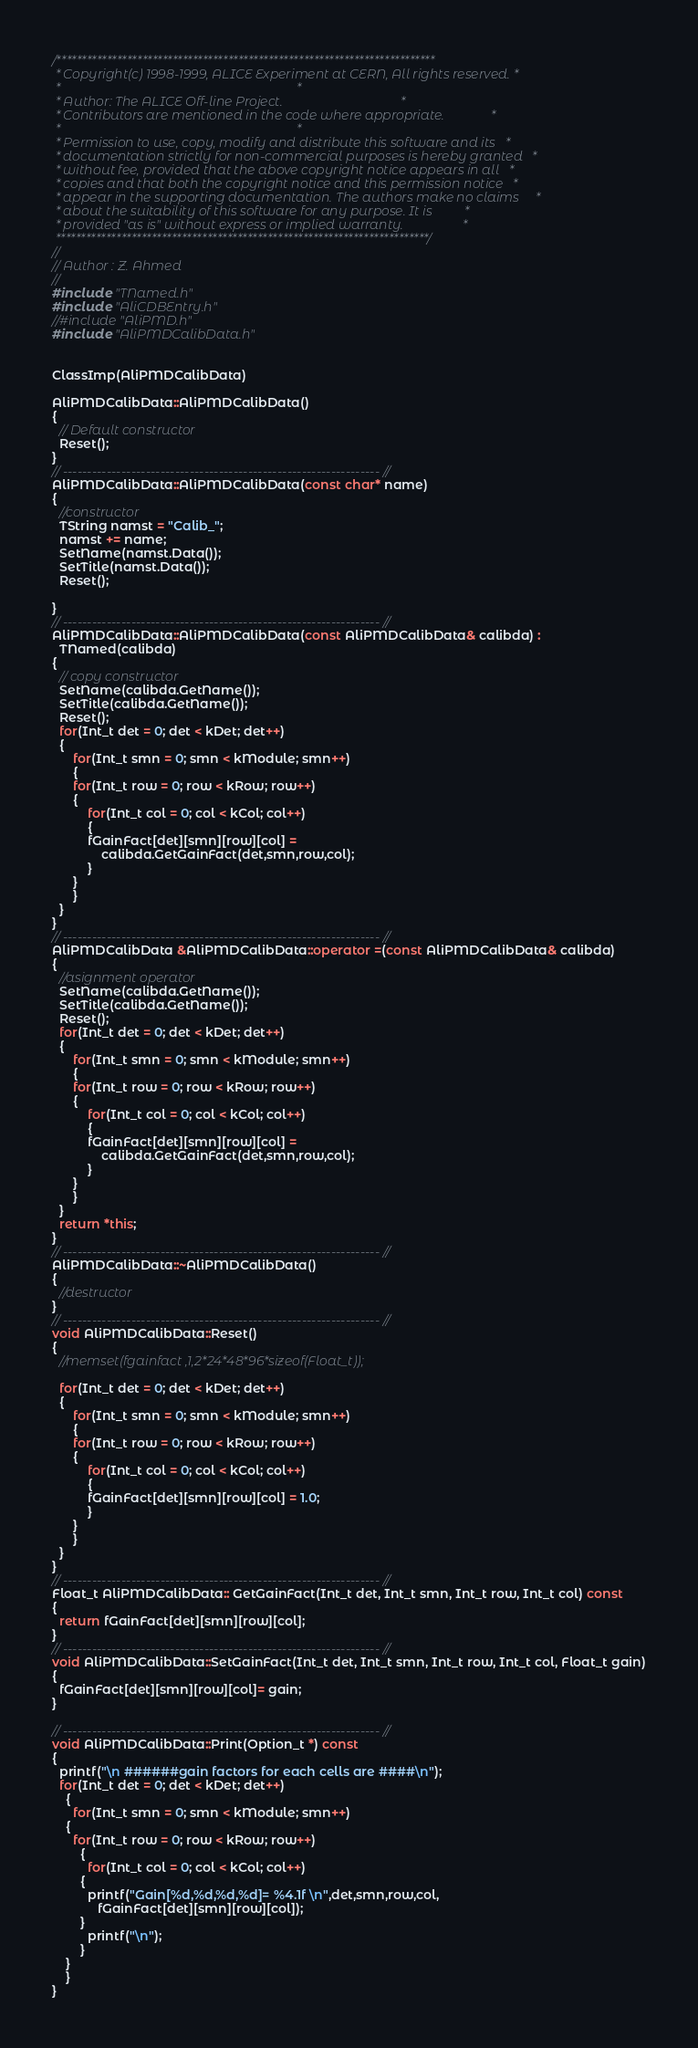<code> <loc_0><loc_0><loc_500><loc_500><_C++_>/***************************************************************************
 * Copyright(c) 1998-1999, ALICE Experiment at CERN, All rights reserved. *
 *                                                                        *
 * Author: The ALICE Off-line Project.                                    *
 * Contributors are mentioned in the code where appropriate.              *
 *                                                                        *
 * Permission to use, copy, modify and distribute this software and its   *
 * documentation strictly for non-commercial purposes is hereby granted   *
 * without fee, provided that the above copyright notice appears in all   *
 * copies and that both the copyright notice and this permission notice   *
 * appear in the supporting documentation. The authors make no claims     *
 * about the suitability of this software for any purpose. It is          *
 * provided "as is" without express or implied warranty.                  *
 **************************************************************************/
//
// Author : Z. Ahmed
//
#include "TNamed.h"
#include "AliCDBEntry.h"
//#include "AliPMD.h"
#include "AliPMDCalibData.h"


ClassImp(AliPMDCalibData)

AliPMDCalibData::AliPMDCalibData()
{
  // Default constructor
  Reset();
}
// ----------------------------------------------------------------- //
AliPMDCalibData::AliPMDCalibData(const char* name)
{
  //constructor
  TString namst = "Calib_";
  namst += name;
  SetName(namst.Data());
  SetTitle(namst.Data());
  Reset();
  
}
// ----------------------------------------------------------------- //
AliPMDCalibData::AliPMDCalibData(const AliPMDCalibData& calibda) :
  TNamed(calibda)
{
  // copy constructor
  SetName(calibda.GetName());
  SetTitle(calibda.GetName());
  Reset();
  for(Int_t det = 0; det < kDet; det++)
  {
      for(Int_t smn = 0; smn < kModule; smn++)
      {
	  for(Int_t row = 0; row < kRow; row++)
	  {
	      for(Int_t col = 0; col < kCol; col++)
	      {
		  fGainFact[det][smn][row][col] = 
		      calibda.GetGainFact(det,smn,row,col);
	      }
	  }
      }
  }
}
// ----------------------------------------------------------------- //
AliPMDCalibData &AliPMDCalibData::operator =(const AliPMDCalibData& calibda)
{
  //asignment operator
  SetName(calibda.GetName());
  SetTitle(calibda.GetName());
  Reset();
  for(Int_t det = 0; det < kDet; det++)
  {
      for(Int_t smn = 0; smn < kModule; smn++)
      {
	  for(Int_t row = 0; row < kRow; row++)
	  {
	      for(Int_t col = 0; col < kCol; col++)
	      {
		  fGainFact[det][smn][row][col] = 
		      calibda.GetGainFact(det,smn,row,col);
	      }
	  }
      }
  }
  return *this;
}
// ----------------------------------------------------------------- //
AliPMDCalibData::~AliPMDCalibData()
{
  //destructor
}
// ----------------------------------------------------------------- //
void AliPMDCalibData::Reset()
{
  //memset(fgainfact ,1,2*24*48*96*sizeof(Float_t));

  for(Int_t det = 0; det < kDet; det++)
  {
      for(Int_t smn = 0; smn < kModule; smn++)
      {
	  for(Int_t row = 0; row < kRow; row++)
	  {
	      for(Int_t col = 0; col < kCol; col++)
	      {
		  fGainFact[det][smn][row][col] = 1.0;
	      }
	  }
      }
  }
}
// ----------------------------------------------------------------- //
Float_t AliPMDCalibData:: GetGainFact(Int_t det, Int_t smn, Int_t row, Int_t col) const
{
  return fGainFact[det][smn][row][col];
}
// ----------------------------------------------------------------- //
void AliPMDCalibData::SetGainFact(Int_t det, Int_t smn, Int_t row, Int_t col, Float_t gain)
{
  fGainFact[det][smn][row][col]= gain;
}

// ----------------------------------------------------------------- //
void AliPMDCalibData::Print(Option_t *) const
{
  printf("\n ######gain factors for each cells are ####\n");
  for(Int_t det = 0; det < kDet; det++)
    {
      for(Int_t smn = 0; smn < kModule; smn++)
	{
	  for(Int_t row = 0; row < kRow; row++)
	    {
	      for(Int_t col = 0; col < kCol; col++)
		{
		  printf("Gain[%d,%d,%d,%d]= %4.1f \n",det,smn,row,col,
			 fGainFact[det][smn][row][col]);
		}
	      printf("\n");
	    }
	}
    }
}
</code> 